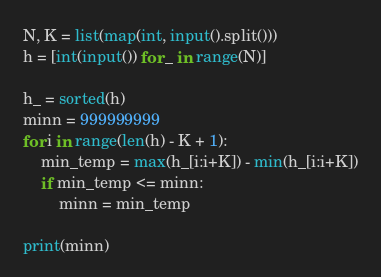<code> <loc_0><loc_0><loc_500><loc_500><_Python_>N, K = list(map(int, input().split()))
h = [int(input()) for _ in range(N)]

h_ = sorted(h)
minn = 999999999
for i in range(len(h) - K + 1):
    min_temp = max(h_[i:i+K]) - min(h_[i:i+K])
    if min_temp <= minn:
        minn = min_temp

print(minn)
</code> 